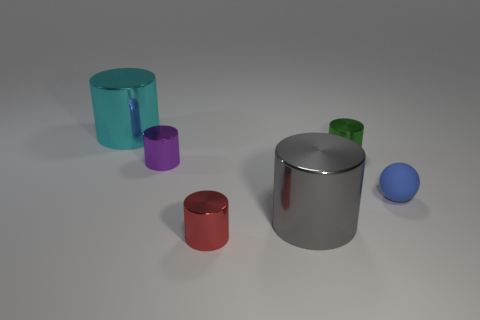Is there a large gray ball that has the same material as the blue thing?
Your response must be concise. No. What is the color of the object to the right of the cylinder that is to the right of the large cylinder that is in front of the small green shiny cylinder?
Ensure brevity in your answer.  Blue. Is the color of the tiny metal object left of the red thing the same as the tiny object in front of the tiny matte object?
Ensure brevity in your answer.  No. Are there any other things that have the same color as the small rubber sphere?
Ensure brevity in your answer.  No. Are there fewer spheres that are on the left side of the large gray cylinder than purple blocks?
Provide a succinct answer. No. What number of tiny purple metallic cylinders are there?
Offer a terse response. 1. There is a gray shiny thing; is it the same shape as the big metal object that is behind the green thing?
Provide a short and direct response. Yes. Is the number of big metal cylinders that are to the right of the sphere less than the number of things in front of the purple metal object?
Your answer should be compact. Yes. Is there any other thing that has the same shape as the red shiny object?
Offer a terse response. Yes. Do the gray metal thing and the purple metallic thing have the same shape?
Offer a very short reply. Yes. 